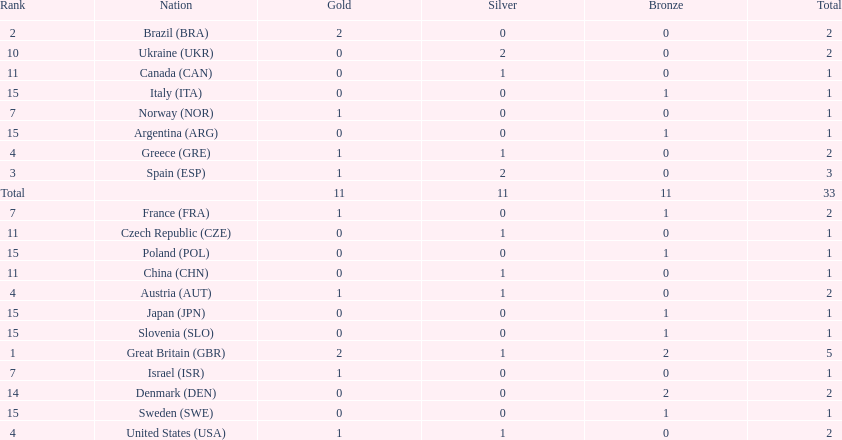How many gold medals did italy receive? 0. 